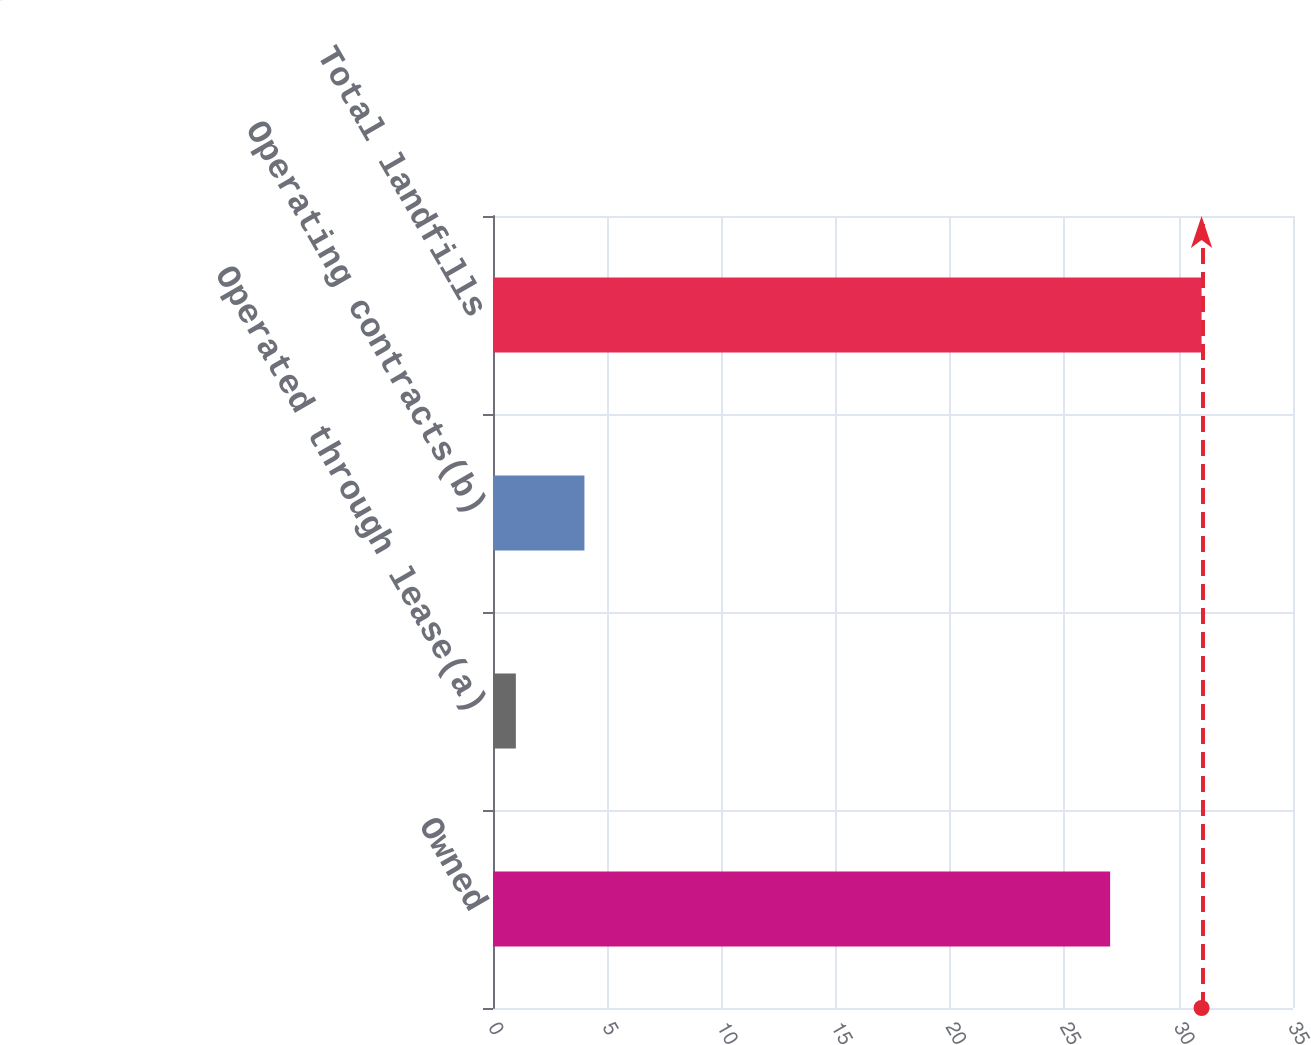Convert chart. <chart><loc_0><loc_0><loc_500><loc_500><bar_chart><fcel>Owned<fcel>Operated through lease(a)<fcel>Operating contracts(b)<fcel>Total landfills<nl><fcel>27<fcel>1<fcel>4<fcel>31<nl></chart> 